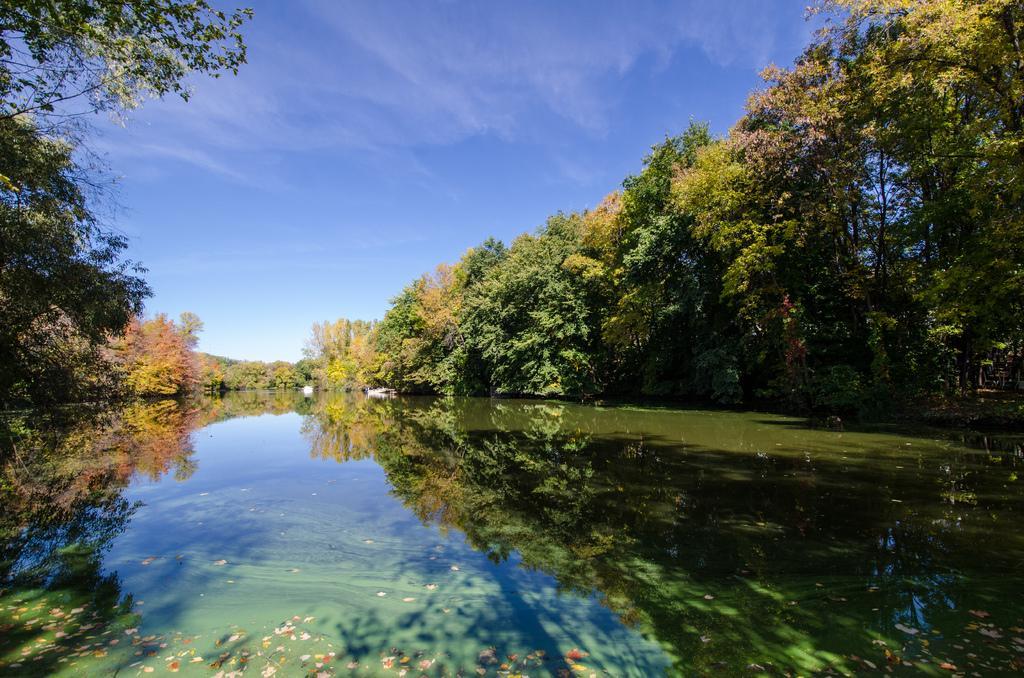Describe this image in one or two sentences. This picture is clicked outside the city. In the foreground we can see a water body. In the background there is a sky and we can see the trees and some plants. 